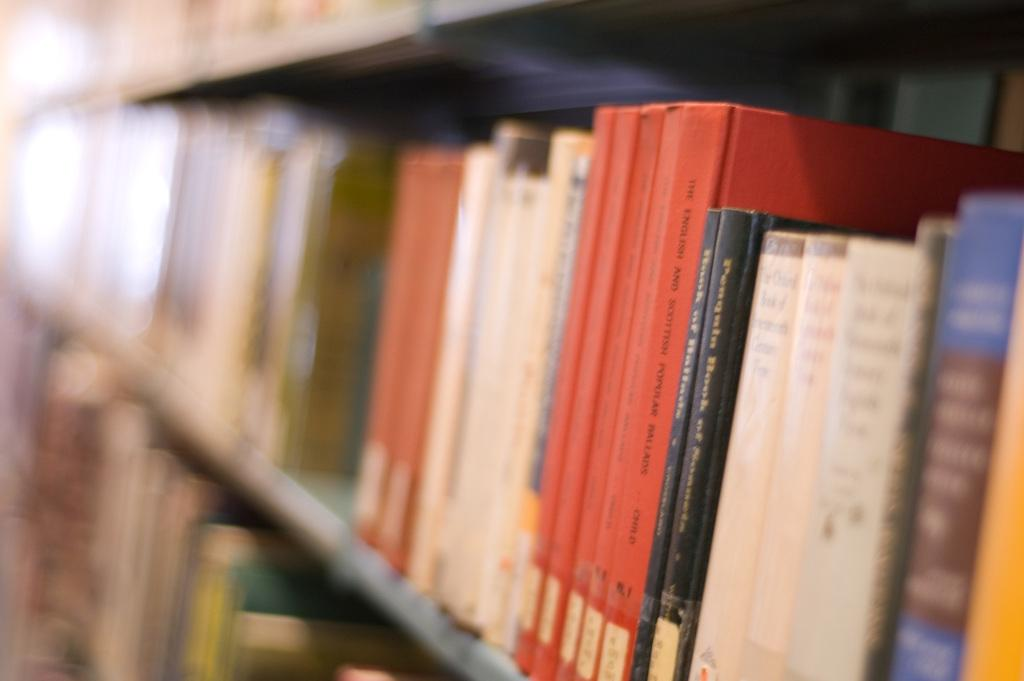What can be seen in the image related to reading materials? There is a pile of books in the image. How are the books arranged in the image? The books are placed in a rack. How many fingers can be seen touching the books in the image? There are no fingers visible in the image, as it only shows a pile of books placed in a rack. 